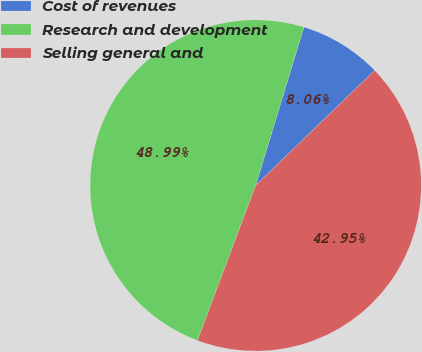<chart> <loc_0><loc_0><loc_500><loc_500><pie_chart><fcel>Cost of revenues<fcel>Research and development<fcel>Selling general and<nl><fcel>8.06%<fcel>48.99%<fcel>42.95%<nl></chart> 